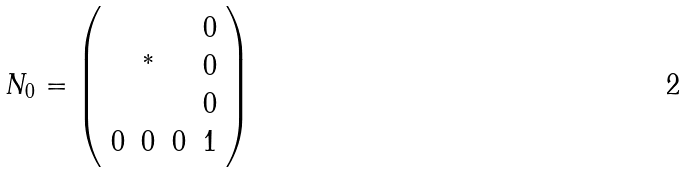<formula> <loc_0><loc_0><loc_500><loc_500>N _ { 0 } = \left ( \begin{array} { c c c c } & & & 0 \\ & { ^ { * } } & & 0 \\ & & & 0 \\ 0 & 0 & 0 & 1 \end{array} \right )</formula> 